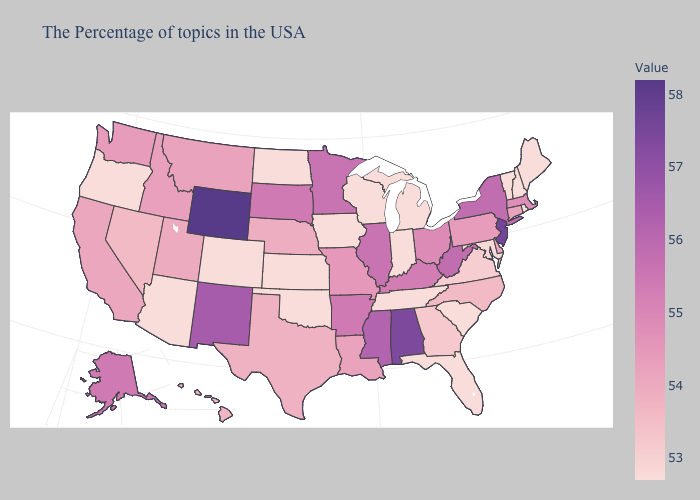Does Illinois have the highest value in the MidWest?
Short answer required. Yes. Which states have the highest value in the USA?
Quick response, please. Wyoming. Does Oregon have the lowest value in the USA?
Write a very short answer. Yes. Does Vermont have a higher value than Idaho?
Concise answer only. No. 